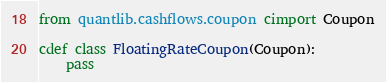Convert code to text. <code><loc_0><loc_0><loc_500><loc_500><_Cython_>from quantlib.cashflows.coupon cimport Coupon

cdef class FloatingRateCoupon(Coupon):
    pass
</code> 